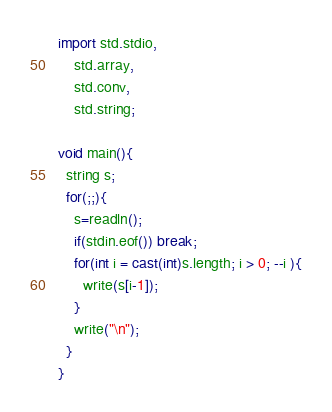Convert code to text. <code><loc_0><loc_0><loc_500><loc_500><_D_>import std.stdio,
    std.array,
    std.conv,
    std.string;

void main(){
  string s;
  for(;;){
    s=readln();
    if(stdin.eof()) break;
    for(int i = cast(int)s.length; i > 0; --i ){
      write(s[i-1]);
    }
    write("\n");
  }
}</code> 